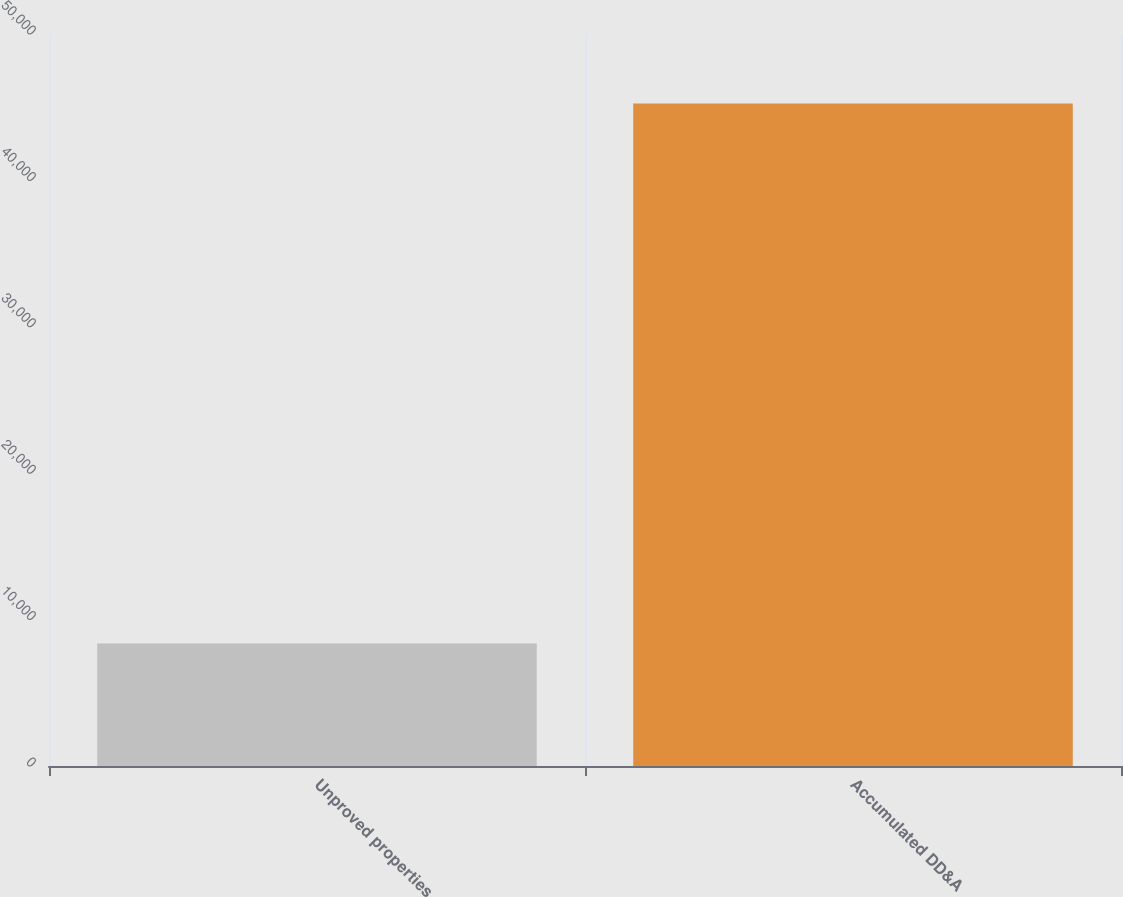Convert chart. <chart><loc_0><loc_0><loc_500><loc_500><bar_chart><fcel>Unproved properties<fcel>Accumulated DD&A<nl><fcel>8363<fcel>45253<nl></chart> 